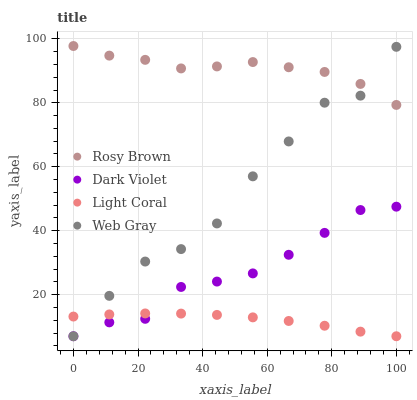Does Light Coral have the minimum area under the curve?
Answer yes or no. Yes. Does Rosy Brown have the maximum area under the curve?
Answer yes or no. Yes. Does Web Gray have the minimum area under the curve?
Answer yes or no. No. Does Web Gray have the maximum area under the curve?
Answer yes or no. No. Is Light Coral the smoothest?
Answer yes or no. Yes. Is Web Gray the roughest?
Answer yes or no. Yes. Is Rosy Brown the smoothest?
Answer yes or no. No. Is Rosy Brown the roughest?
Answer yes or no. No. Does Light Coral have the lowest value?
Answer yes or no. Yes. Does Rosy Brown have the lowest value?
Answer yes or no. No. Does Rosy Brown have the highest value?
Answer yes or no. Yes. Does Web Gray have the highest value?
Answer yes or no. No. Is Dark Violet less than Rosy Brown?
Answer yes or no. Yes. Is Rosy Brown greater than Dark Violet?
Answer yes or no. Yes. Does Web Gray intersect Dark Violet?
Answer yes or no. Yes. Is Web Gray less than Dark Violet?
Answer yes or no. No. Is Web Gray greater than Dark Violet?
Answer yes or no. No. Does Dark Violet intersect Rosy Brown?
Answer yes or no. No. 